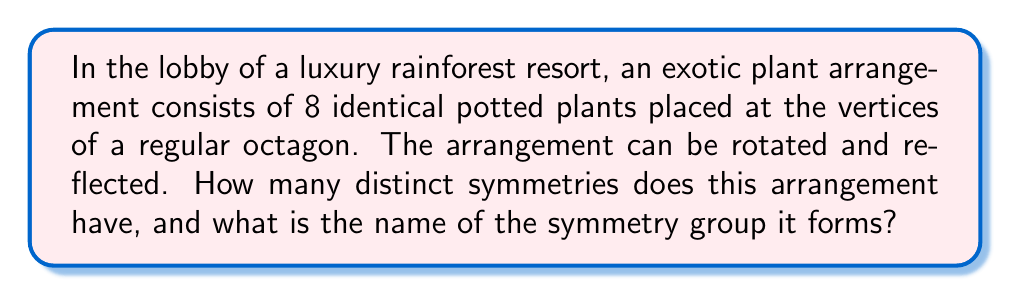What is the answer to this math problem? Let's approach this step-by-step:

1) The symmetries of a regular octagon form the dihedral group $D_8$.

2) To count the symmetries:
   a) Rotational symmetries: The arrangement can be rotated by multiples of 45° (360°/8). This gives 8 rotational symmetries (including the identity rotation).
   b) Reflection symmetries: There are 8 lines of reflection - 4 passing through opposite vertices and 4 passing through the midpoints of opposite sides.

3) Total number of symmetries: 8 (rotations) + 8 (reflections) = 16

4) The group formed by these symmetries is indeed $D_8$, the dihedral group of order 16.

5) Properties of $D_8$:
   - It has 16 elements
   - It is non-abelian
   - It can be generated by two elements: a rotation $r$ by 45° and a reflection $s$
   - Its presentation is $\langle r,s | r^8 = s^2 = 1, srs = r^{-1} \rangle$

6) In the context of the resort:
   - Rotations represent viewing the arrangement from different angles
   - Reflections represent mirror images of the arrangement
   - The group structure ensures that any combination of these operations results in another valid view of the arrangement

This group theory analysis provides a mathematical foundation for understanding the symmetry of the exotic plant arrangement, enhancing the aesthetic appeal of the resort lobby while maintaining a controlled, risk-free environment compared to actual jungle experiences.
Answer: 16 symmetries; Dihedral group $D_8$ 